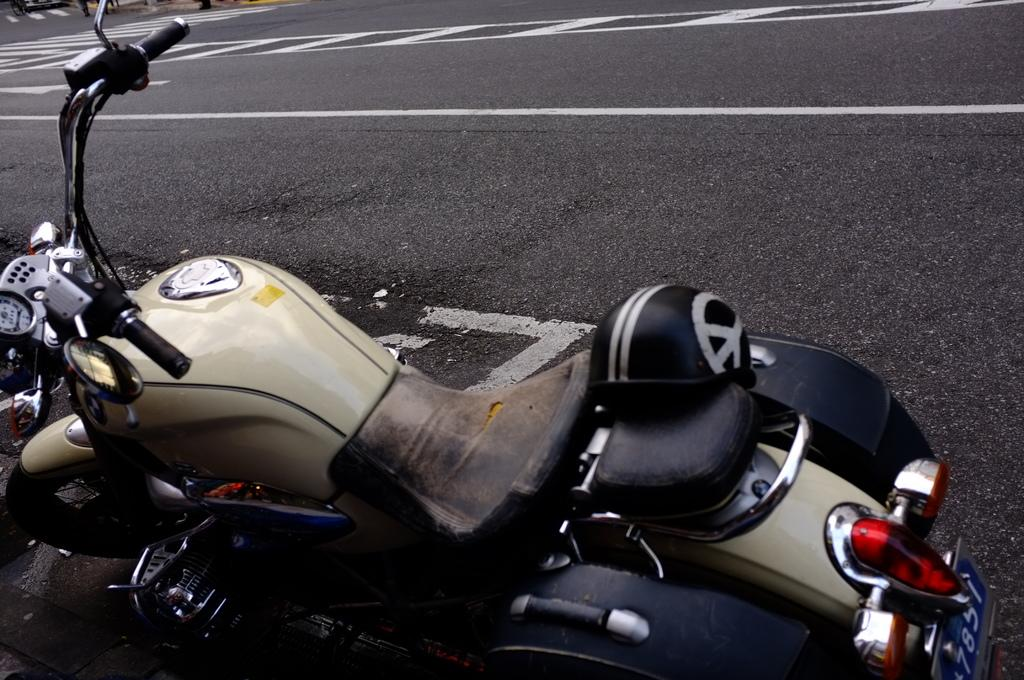What is located at the bottom of the image? There is a bike in the bottom of the image. What can be seen at the top of the image? There is a road in the top of the image. What type of mint is growing on the side of the road in the image? There is no mint present in the image; it only features a bike at the bottom and a road at the top. 